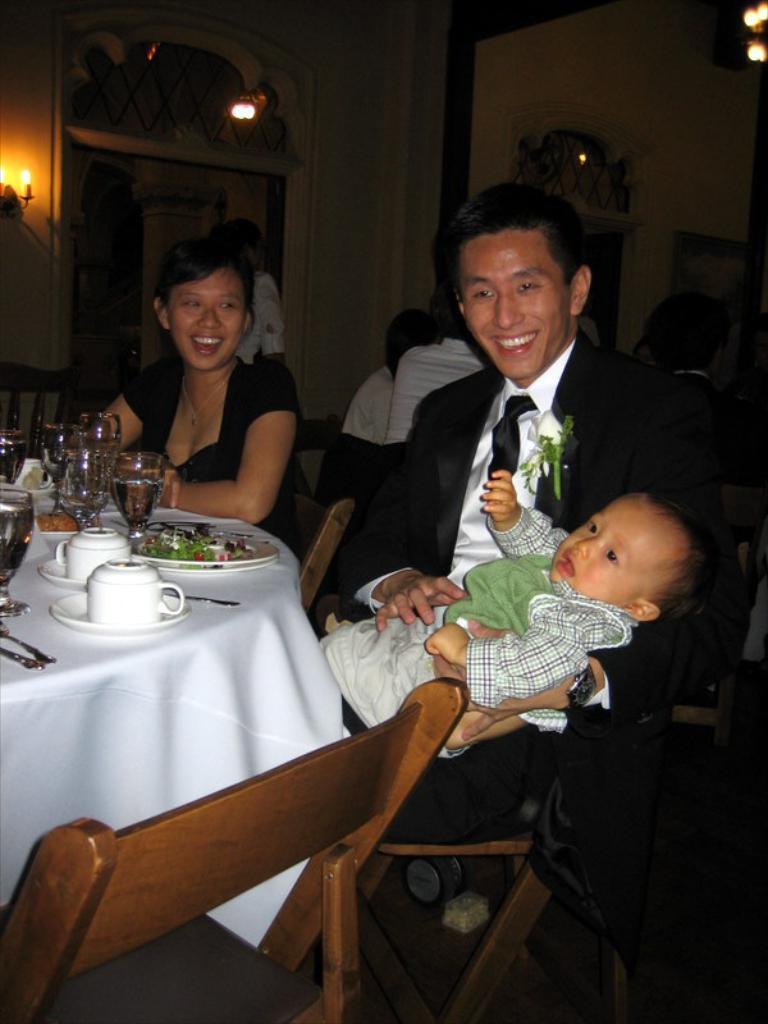In one or two sentences, can you explain what this image depicts? This picture clicked inside a restaurant. There are few people sitting on chairs at the tables. On the table there are glasses, cup and saucer, plates, food and spoons. The man in the center is wearing a black suit and holding a kid in his hand. In the background there is wall, lamps and chandelier. 